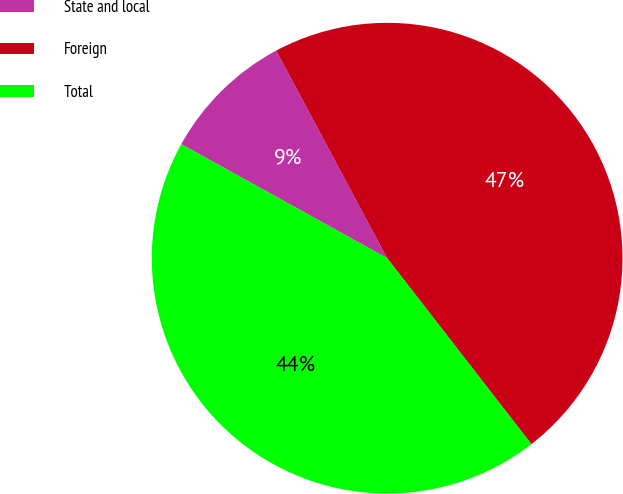<chart> <loc_0><loc_0><loc_500><loc_500><pie_chart><fcel>State and local<fcel>Foreign<fcel>Total<nl><fcel>9.14%<fcel>47.32%<fcel>43.55%<nl></chart> 